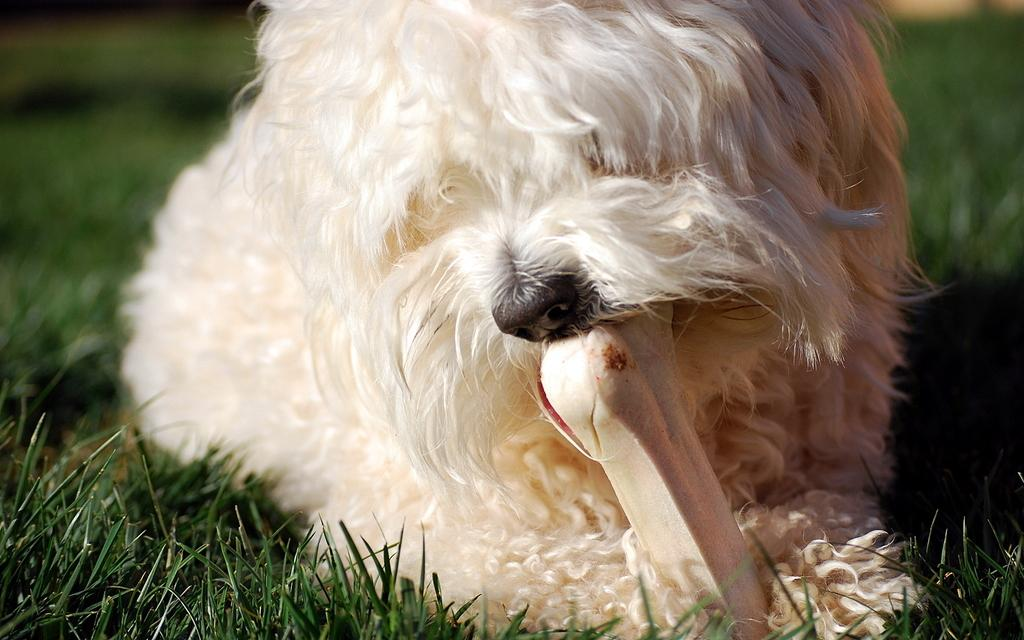What type of surface is visible on the ground in the image? The ground in the image is covered with grass. What animal can be seen in the image? There is a white-colored dog in the image. What object is present in the image that might be of interest to the dog? There is a white-colored bone in the image. Who is the manager of the dog in the image? There is no manager present in the image, as it features a dog and a bone in a grassy area. 